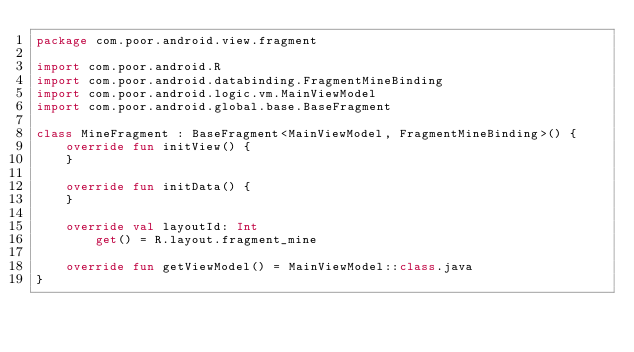<code> <loc_0><loc_0><loc_500><loc_500><_Kotlin_>package com.poor.android.view.fragment

import com.poor.android.R
import com.poor.android.databinding.FragmentMineBinding
import com.poor.android.logic.vm.MainViewModel
import com.poor.android.global.base.BaseFragment

class MineFragment : BaseFragment<MainViewModel, FragmentMineBinding>() {
    override fun initView() {
    }

    override fun initData() {
    }

    override val layoutId: Int
        get() = R.layout.fragment_mine

    override fun getViewModel() = MainViewModel::class.java
}</code> 